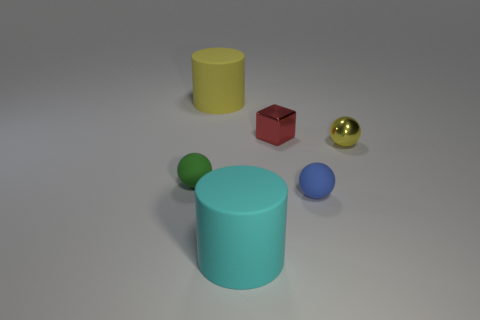There is a tiny metallic block; does it have the same color as the matte object in front of the small blue rubber sphere?
Ensure brevity in your answer.  No. What is the material of the green sphere that is the same size as the block?
Keep it short and to the point. Rubber. Is the number of green things on the right side of the shiny sphere less than the number of cylinders that are in front of the large cyan thing?
Offer a very short reply. No. What shape is the big thing that is in front of the rubber cylinder behind the small green matte ball?
Your answer should be very brief. Cylinder. Are there any brown matte balls?
Give a very brief answer. No. What is the color of the rubber sphere on the right side of the small green ball?
Provide a succinct answer. Blue. There is a big cylinder that is the same color as the metallic ball; what is it made of?
Offer a terse response. Rubber. There is a tiny green rubber ball; are there any tiny blue matte spheres behind it?
Provide a short and direct response. No. Is the number of tiny yellow spheres greater than the number of tiny purple shiny cylinders?
Your response must be concise. Yes. What color is the big matte object in front of the small rubber sphere that is right of the large rubber cylinder that is in front of the green object?
Make the answer very short. Cyan. 